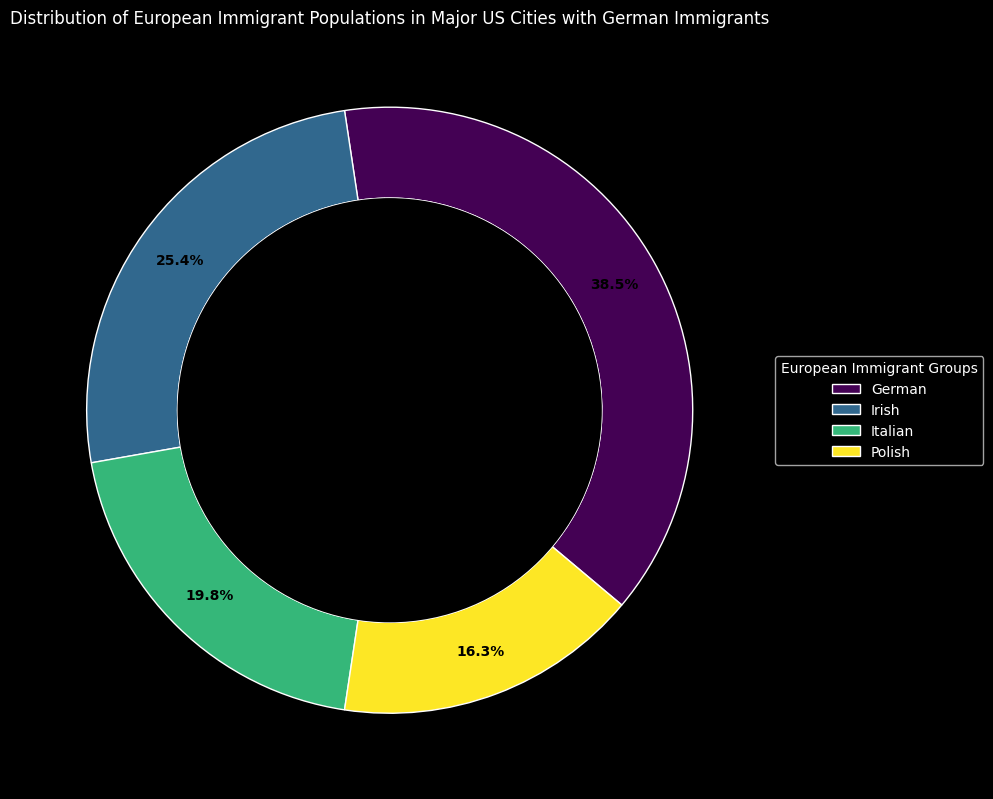What's the total percentage of German immigrants in Los Angeles and San Diego? Add the percentages of German immigrants in Los Angeles (10%) and San Diego (7%). 10 + 7 = 17
Answer: 17 Which city has the highest percentage of German immigrants? Compare the percentage values of German immigrants across all cities. Chicago has the highest at 20%.
Answer: Chicago What is the average percentage of Irish immigrants in New York and Philadelphia? Add the percentages of Irish immigrants in New York (12%) and Philadelphia (9%), then divide by 2. (12 + 9) / 2 = 21 / 2 = 10.5
Answer: 10.5 Which immigrant group has the smallest total percentage of population in San Antonio? Compare the percentages across German (6%), Irish (3%), Italian (2%), and Polish (1%) immigrants in San Antonio. Polish immigrants have the smallest percentage.
Answer: Polish Are there more German immigrants in Houston or Irish immigrants in Chicago? Compare the percentage values: German immigrants in Houston (8%) vs. Irish immigrants in Chicago (11%). Irish immigrants in Chicago have a higher percentage.
Answer: Irish immigrants in Chicago Which group has a greater total percentage of immigrants in New York, the Germans or the Italians? Compare the total percentages: German immigrants in New York (15%) vs. Italian immigrants in New York (10%). German immigrants have a higher percentage.
Answer: German immigrants What is the combined percentage of Italian and Polish immigrants in Phoenix? Add the percentages of Italian (3%) and Polish (2%) immigrants in Phoenix. 3 + 2 = 5
Answer: 5 Which group occupies the largest segment in the outer circle of the chart? The outer circle segments represent the total percentages of each European immigrant group. The German group has the largest segment.
Answer: German Which city contributes a larger share to the total percentage of Polish immigrants, San Diego or Dallas? Compare the percentage values of Polish immigrants in San Diego (3%) vs. Dallas (3%). They are equal.
Answer: Equal What is the percentage difference between German immigrants in Dallas and San Jose? Subtract the percentage of German immigrants in San Jose (5%) from that in Dallas (9%). 9 - 5 = 4
Answer: 4 